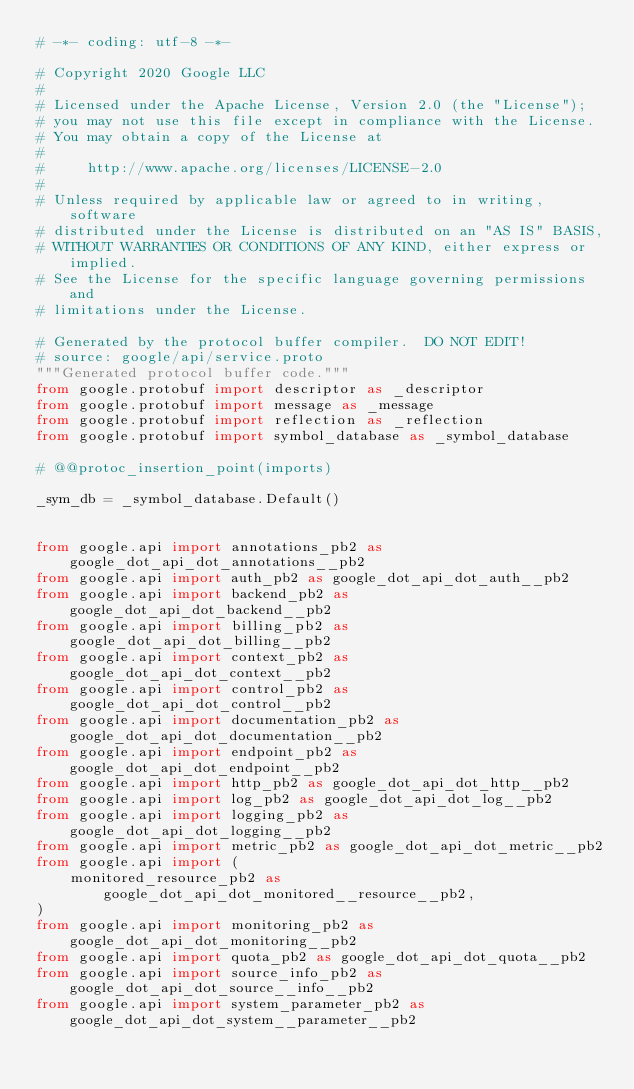Convert code to text. <code><loc_0><loc_0><loc_500><loc_500><_Python_># -*- coding: utf-8 -*-

# Copyright 2020 Google LLC
#
# Licensed under the Apache License, Version 2.0 (the "License");
# you may not use this file except in compliance with the License.
# You may obtain a copy of the License at
#
#     http://www.apache.org/licenses/LICENSE-2.0
#
# Unless required by applicable law or agreed to in writing, software
# distributed under the License is distributed on an "AS IS" BASIS,
# WITHOUT WARRANTIES OR CONDITIONS OF ANY KIND, either express or implied.
# See the License for the specific language governing permissions and
# limitations under the License.

# Generated by the protocol buffer compiler.  DO NOT EDIT!
# source: google/api/service.proto
"""Generated protocol buffer code."""
from google.protobuf import descriptor as _descriptor
from google.protobuf import message as _message
from google.protobuf import reflection as _reflection
from google.protobuf import symbol_database as _symbol_database

# @@protoc_insertion_point(imports)

_sym_db = _symbol_database.Default()


from google.api import annotations_pb2 as google_dot_api_dot_annotations__pb2
from google.api import auth_pb2 as google_dot_api_dot_auth__pb2
from google.api import backend_pb2 as google_dot_api_dot_backend__pb2
from google.api import billing_pb2 as google_dot_api_dot_billing__pb2
from google.api import context_pb2 as google_dot_api_dot_context__pb2
from google.api import control_pb2 as google_dot_api_dot_control__pb2
from google.api import documentation_pb2 as google_dot_api_dot_documentation__pb2
from google.api import endpoint_pb2 as google_dot_api_dot_endpoint__pb2
from google.api import http_pb2 as google_dot_api_dot_http__pb2
from google.api import log_pb2 as google_dot_api_dot_log__pb2
from google.api import logging_pb2 as google_dot_api_dot_logging__pb2
from google.api import metric_pb2 as google_dot_api_dot_metric__pb2
from google.api import (
    monitored_resource_pb2 as google_dot_api_dot_monitored__resource__pb2,
)
from google.api import monitoring_pb2 as google_dot_api_dot_monitoring__pb2
from google.api import quota_pb2 as google_dot_api_dot_quota__pb2
from google.api import source_info_pb2 as google_dot_api_dot_source__info__pb2
from google.api import system_parameter_pb2 as google_dot_api_dot_system__parameter__pb2</code> 